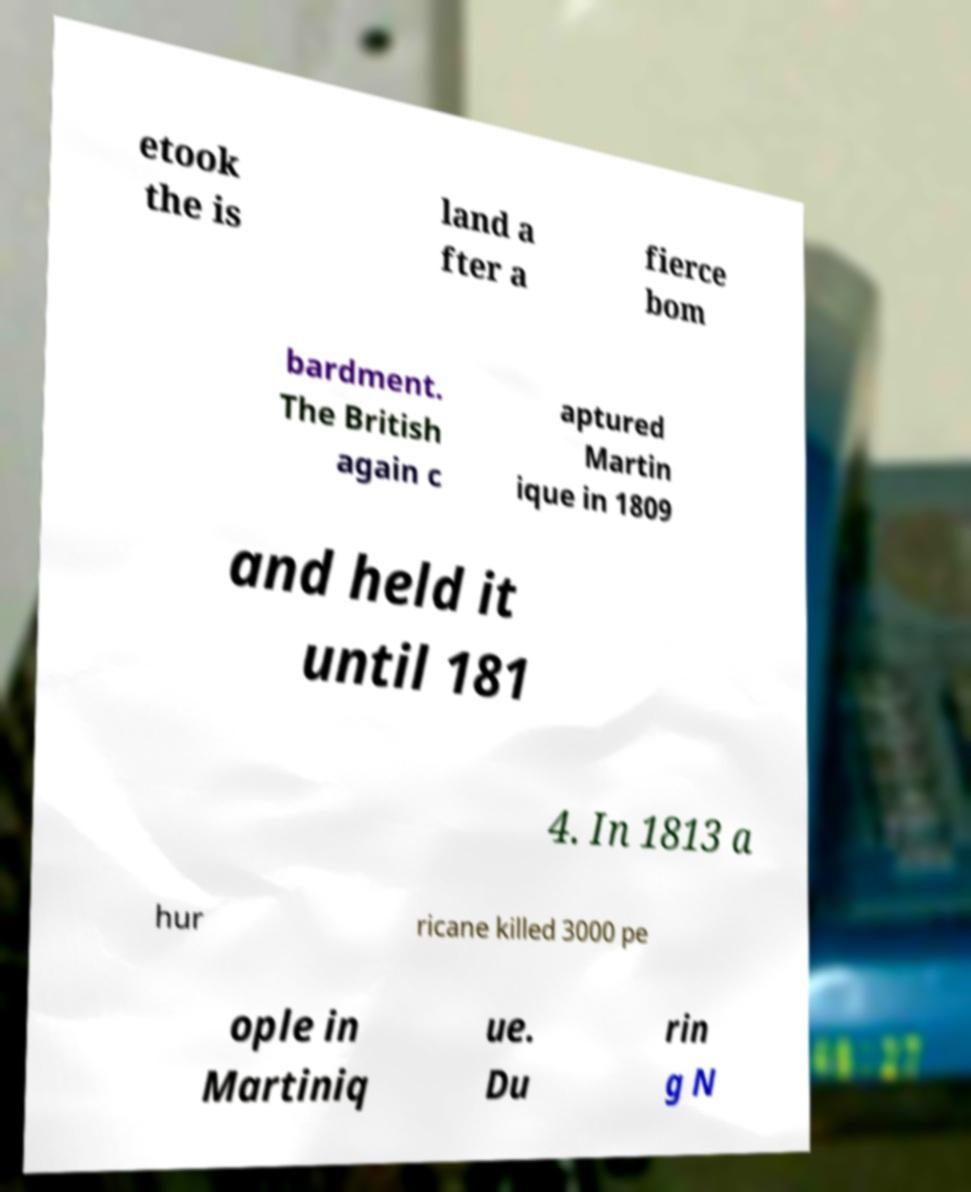What messages or text are displayed in this image? I need them in a readable, typed format. etook the is land a fter a fierce bom bardment. The British again c aptured Martin ique in 1809 and held it until 181 4. In 1813 a hur ricane killed 3000 pe ople in Martiniq ue. Du rin g N 